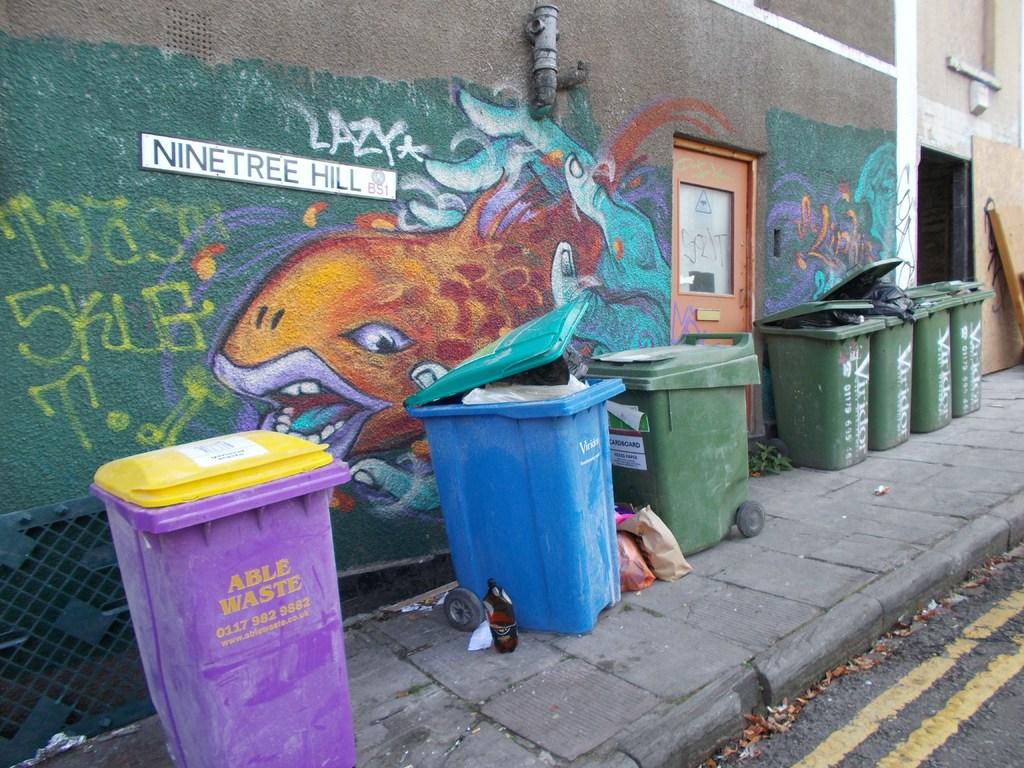What does the purple waste bin read?
Offer a terse response. Able waste. What does the white sign say?
Provide a succinct answer. Ninetree hill. 